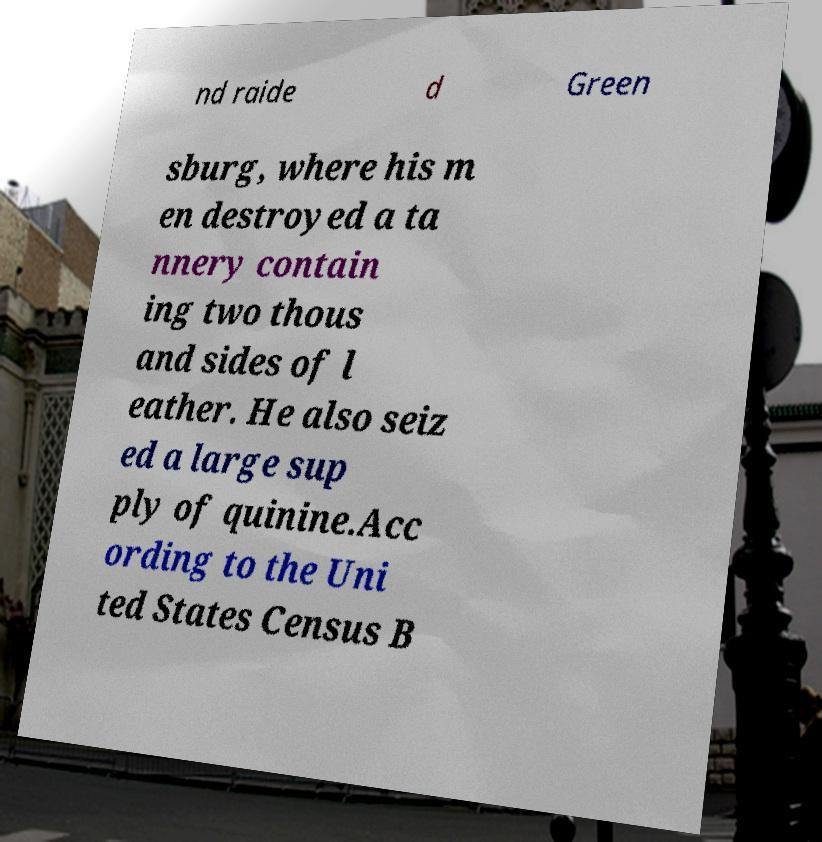Please read and relay the text visible in this image. What does it say? nd raide d Green sburg, where his m en destroyed a ta nnery contain ing two thous and sides of l eather. He also seiz ed a large sup ply of quinine.Acc ording to the Uni ted States Census B 